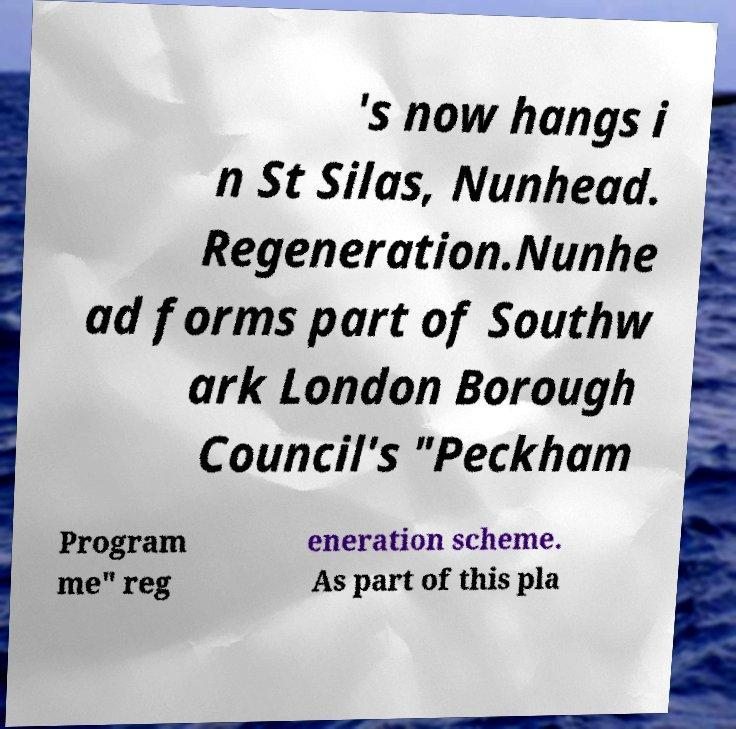For documentation purposes, I need the text within this image transcribed. Could you provide that? 's now hangs i n St Silas, Nunhead. Regeneration.Nunhe ad forms part of Southw ark London Borough Council's "Peckham Program me" reg eneration scheme. As part of this pla 